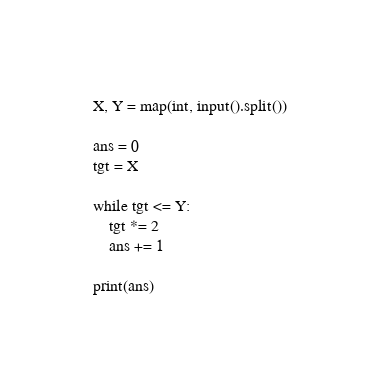<code> <loc_0><loc_0><loc_500><loc_500><_Python_>X, Y = map(int, input().split())

ans = 0
tgt = X

while tgt <= Y:
    tgt *= 2
    ans += 1

print(ans)
</code> 